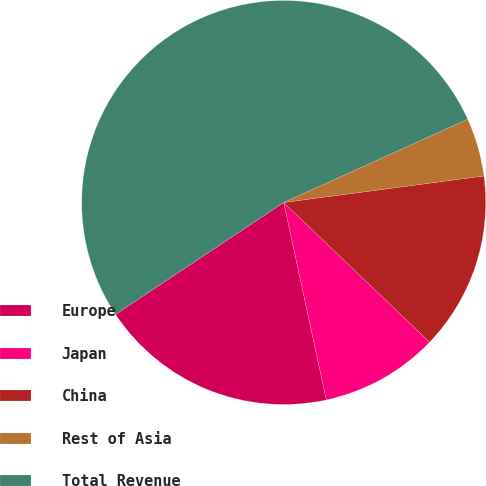<chart> <loc_0><loc_0><loc_500><loc_500><pie_chart><fcel>Europe<fcel>Japan<fcel>China<fcel>Rest of Asia<fcel>Total Revenue<nl><fcel>19.04%<fcel>9.46%<fcel>14.25%<fcel>4.67%<fcel>52.58%<nl></chart> 